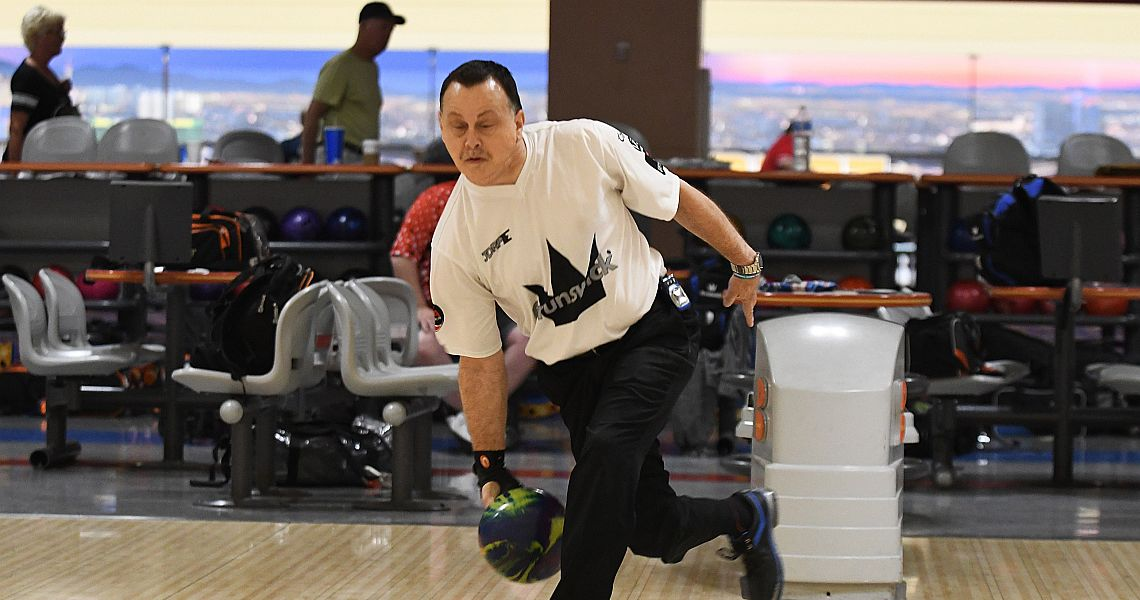Imagine if this event took place in a futuristic bowling alley on a spaceship. Describe the ambiance and technological advancements that might be present. In a futuristic bowling alley set on a spaceship, the ambiance would likely be a blend of sleek, high-tech design and otherworldly aesthetics. The lanes could be made of a self-repairing material that adjusts to the bowler's play style, ensuring optimal performance. Holographic displays around the alley would provide real-time statistics, immersive game replays, and even virtual coaches offering tips. Participants might use advanced, customizable bowling balls with built-in sensors to track and enhance their performance. The spaceship's viewports could offer stunning vistas of interstellar scenery, adding to the unique and awe-inspiring experience. Automated drones might serve refreshments, and augmented reality elements could turn each game into an interactive adventure, with themes changing based on player preference. The sound system would create a dynamic audio environment, using spatial audio to make players feel like they're in the midst of an epic cosmic game. 